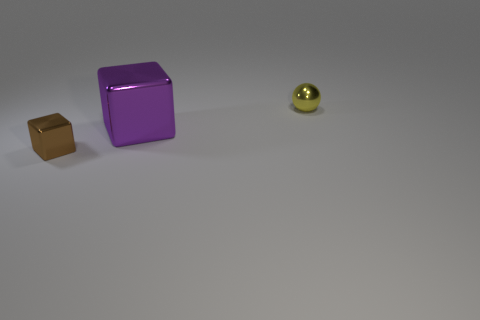Subtract all brown blocks. How many blocks are left? 1 Add 2 brown things. How many objects exist? 5 Subtract all green cubes. Subtract all brown cylinders. How many cubes are left? 2 Subtract all brown cylinders. How many green balls are left? 0 Subtract all tiny shiny balls. Subtract all purple metallic cubes. How many objects are left? 1 Add 3 small shiny objects. How many small shiny objects are left? 5 Add 1 small metallic balls. How many small metallic balls exist? 2 Subtract 0 brown cylinders. How many objects are left? 3 Subtract all blocks. How many objects are left? 1 